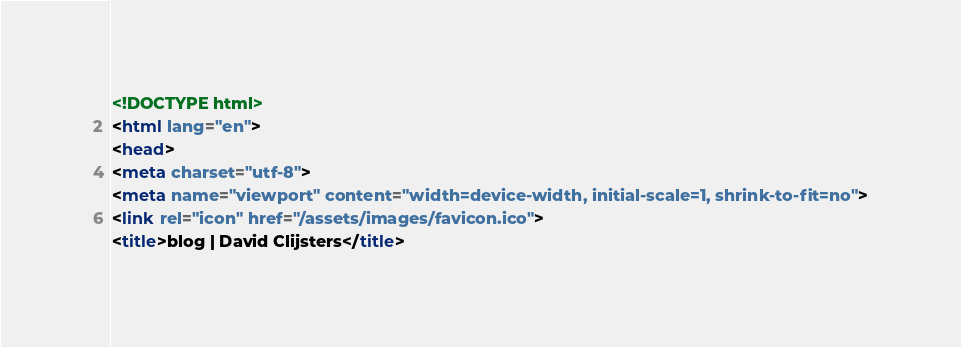Convert code to text. <code><loc_0><loc_0><loc_500><loc_500><_HTML_><!DOCTYPE html>
<html lang="en">
<head>
<meta charset="utf-8">
<meta name="viewport" content="width=device-width, initial-scale=1, shrink-to-fit=no">
<link rel="icon" href="/assets/images/favicon.ico">
<title>blog | David Clijsters</title>
</code> 